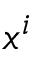Convert formula to latex. <formula><loc_0><loc_0><loc_500><loc_500>x ^ { i }</formula> 